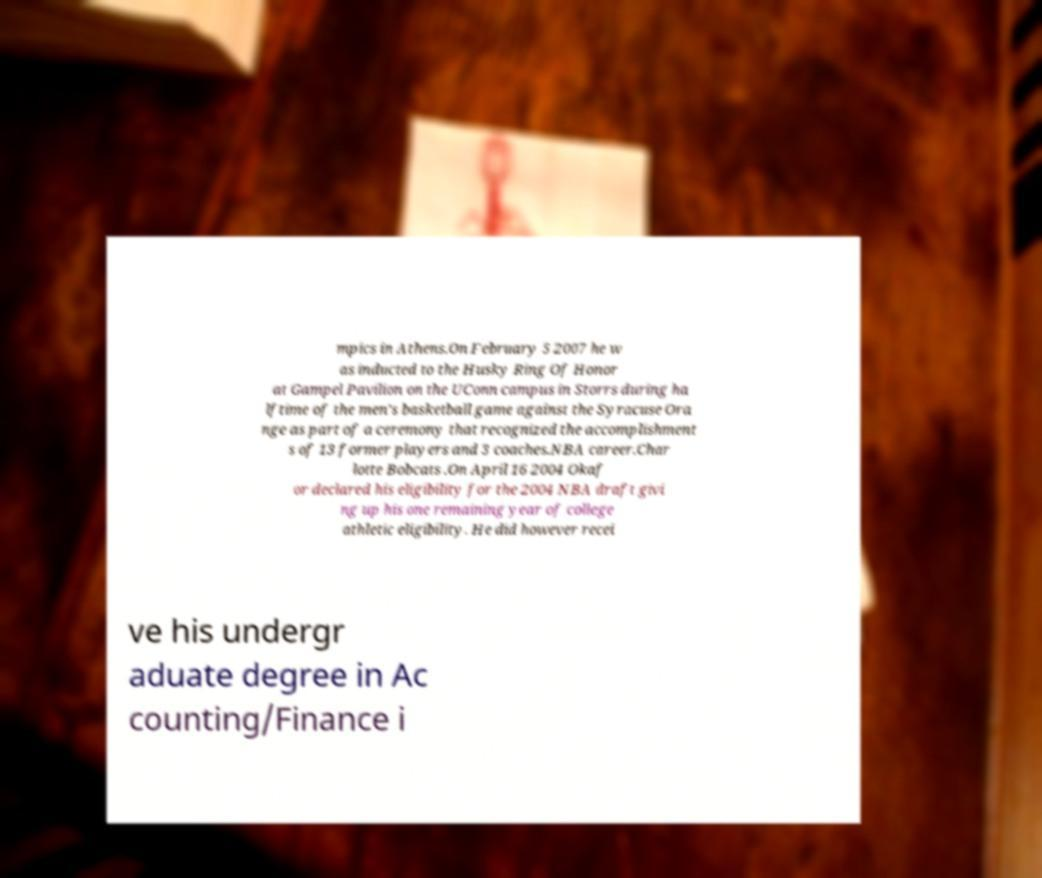Can you read and provide the text displayed in the image?This photo seems to have some interesting text. Can you extract and type it out for me? mpics in Athens.On February 5 2007 he w as inducted to the Husky Ring Of Honor at Gampel Pavilion on the UConn campus in Storrs during ha lftime of the men's basketball game against the Syracuse Ora nge as part of a ceremony that recognized the accomplishment s of 13 former players and 3 coaches.NBA career.Char lotte Bobcats .On April 16 2004 Okaf or declared his eligibility for the 2004 NBA draft givi ng up his one remaining year of college athletic eligibility. He did however recei ve his undergr aduate degree in Ac counting/Finance i 